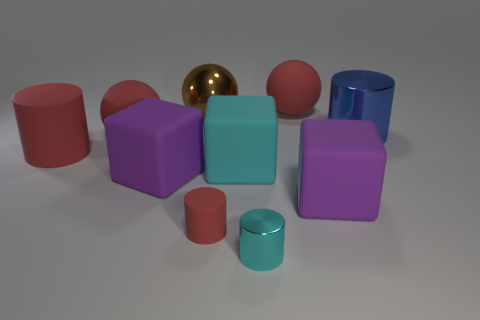There is a big cylinder on the right side of the large matte cylinder that is to the left of the large red matte sphere in front of the blue metal cylinder; what is its material?
Give a very brief answer. Metal. Do the brown ball and the blue object have the same size?
Give a very brief answer. Yes. What material is the cyan cube?
Your answer should be very brief. Rubber. There is a large object that is the same color as the tiny metallic cylinder; what is its material?
Provide a succinct answer. Rubber. There is a large matte object behind the blue metal object; does it have the same shape as the large brown metal thing?
Your answer should be very brief. Yes. How many objects are large metallic objects or big cyan rubber objects?
Give a very brief answer. 3. Does the cylinder on the right side of the cyan metal thing have the same material as the cyan cube?
Offer a terse response. No. How big is the brown metal ball?
Your answer should be very brief. Large. What is the shape of the large rubber thing that is the same color as the small metallic object?
Your answer should be very brief. Cube. How many blocks are either green metallic things or big shiny objects?
Provide a short and direct response. 0. 